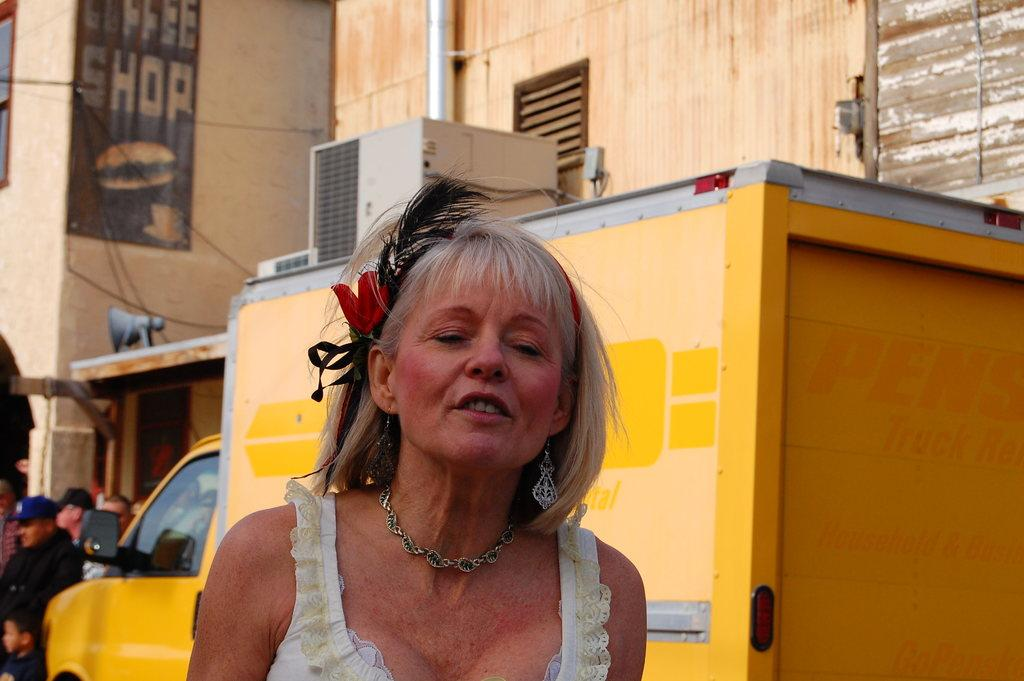<image>
Relay a brief, clear account of the picture shown. A woman with a ribbon in her hair is standing by a yellow moving track that says Pens Truck Rental. 